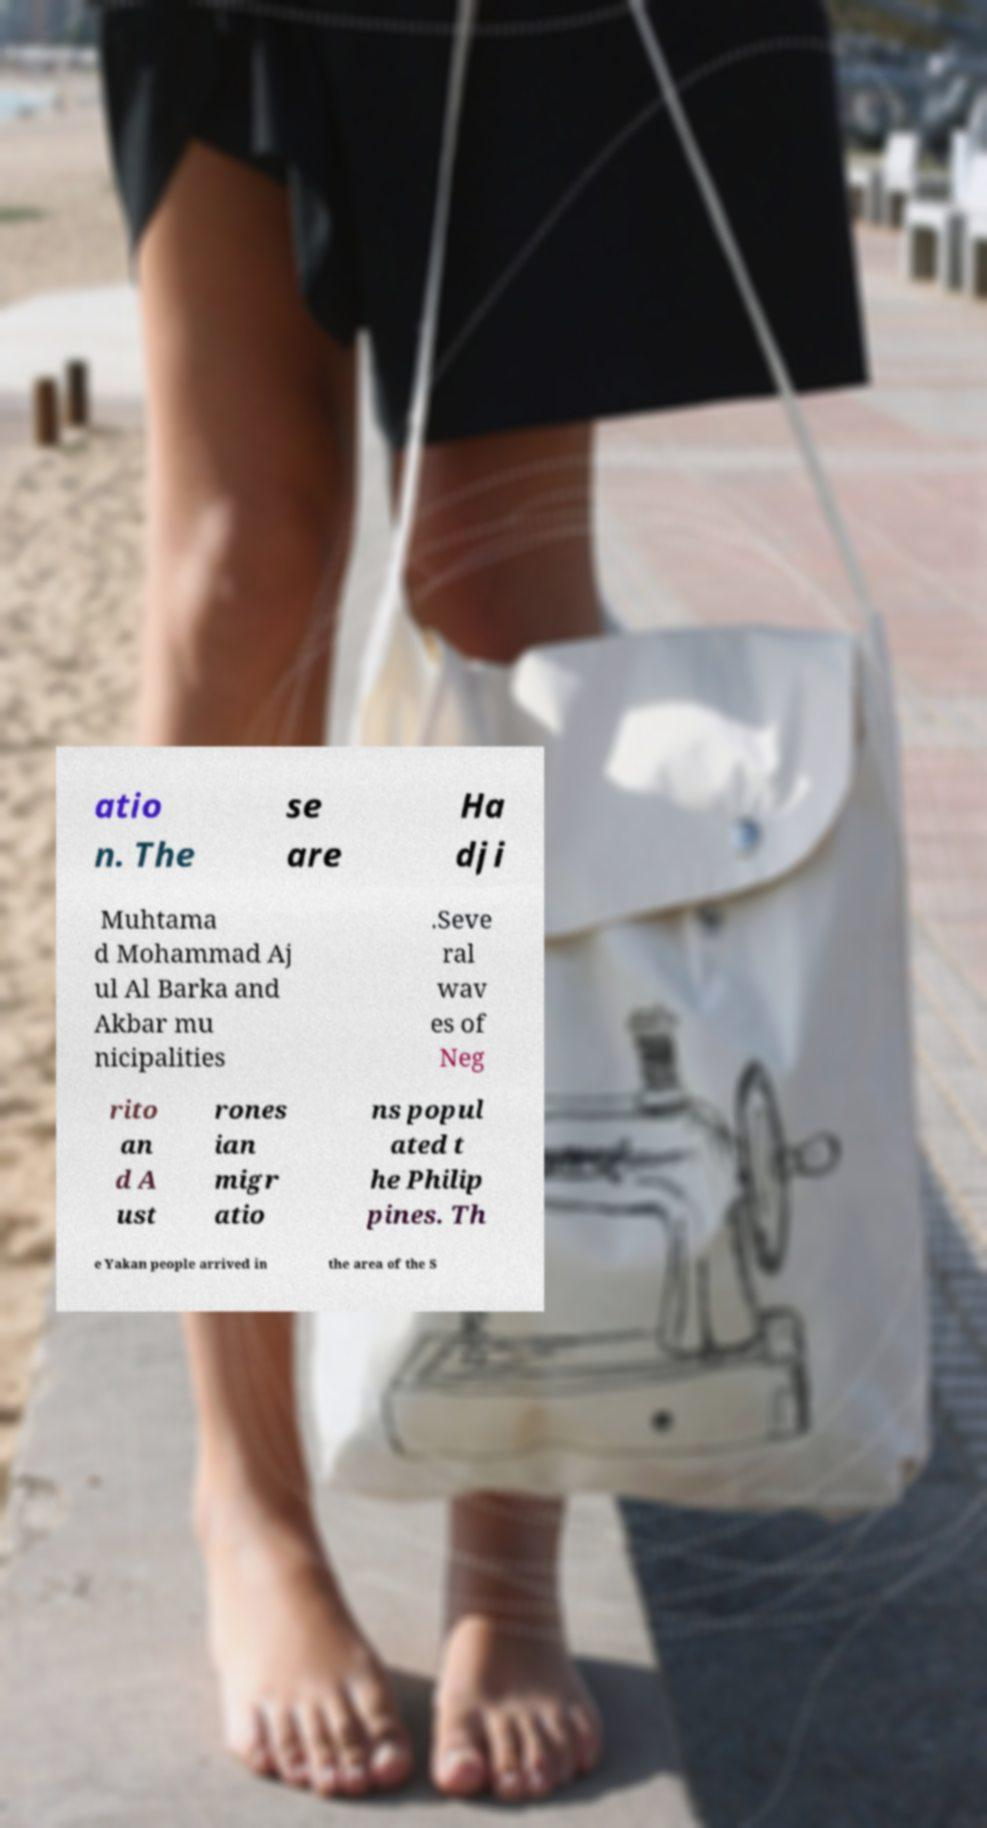Please read and relay the text visible in this image. What does it say? atio n. The se are Ha dji Muhtama d Mohammad Aj ul Al Barka and Akbar mu nicipalities .Seve ral wav es of Neg rito an d A ust rones ian migr atio ns popul ated t he Philip pines. Th e Yakan people arrived in the area of the S 